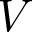<formula> <loc_0><loc_0><loc_500><loc_500>V</formula> 